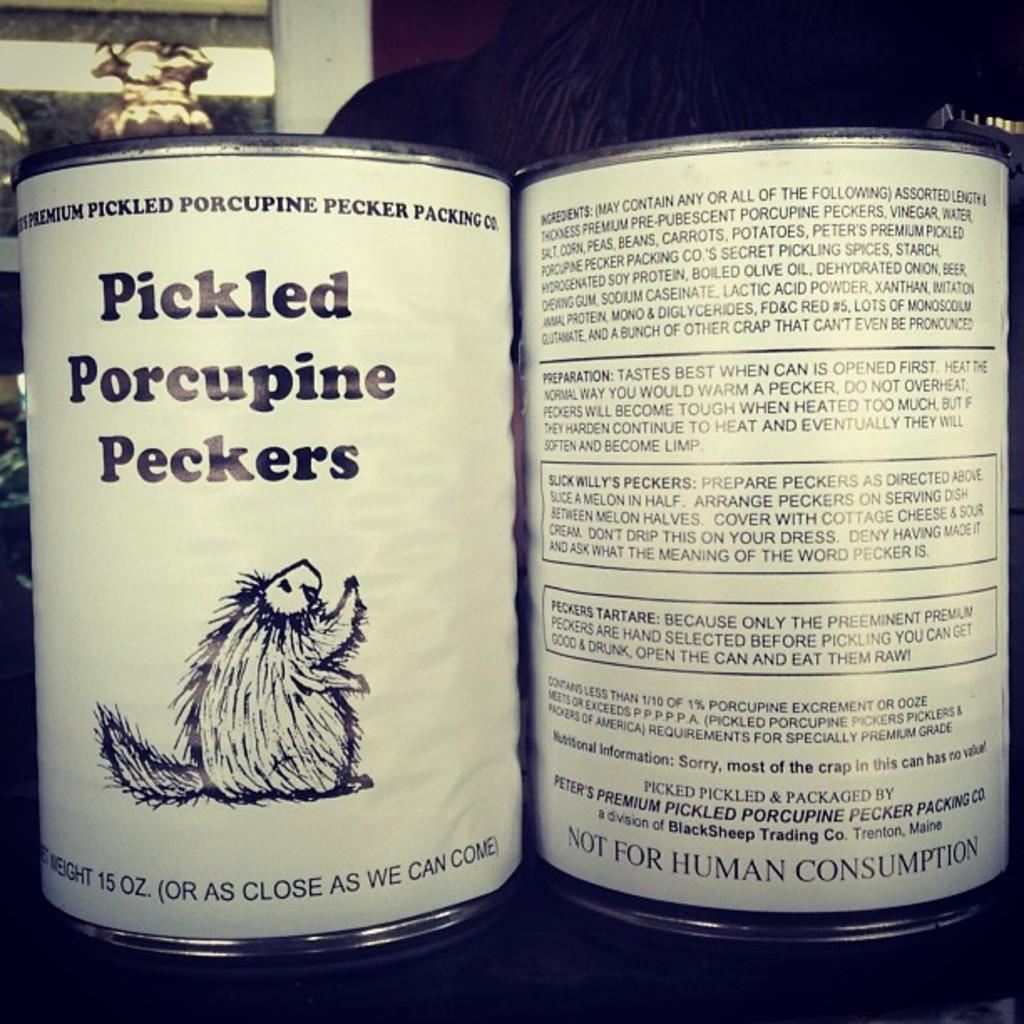How many cans are visible in the image? There are two cans in the image. What can be found on the cans? There is text written on the cans. What is located in the background of the image? There is a wall in the image. What is attached to the wall? There are objects on the wall. What is the weight of the carpenter in the image? There is no carpenter present in the image, so it is not possible to determine their weight. 